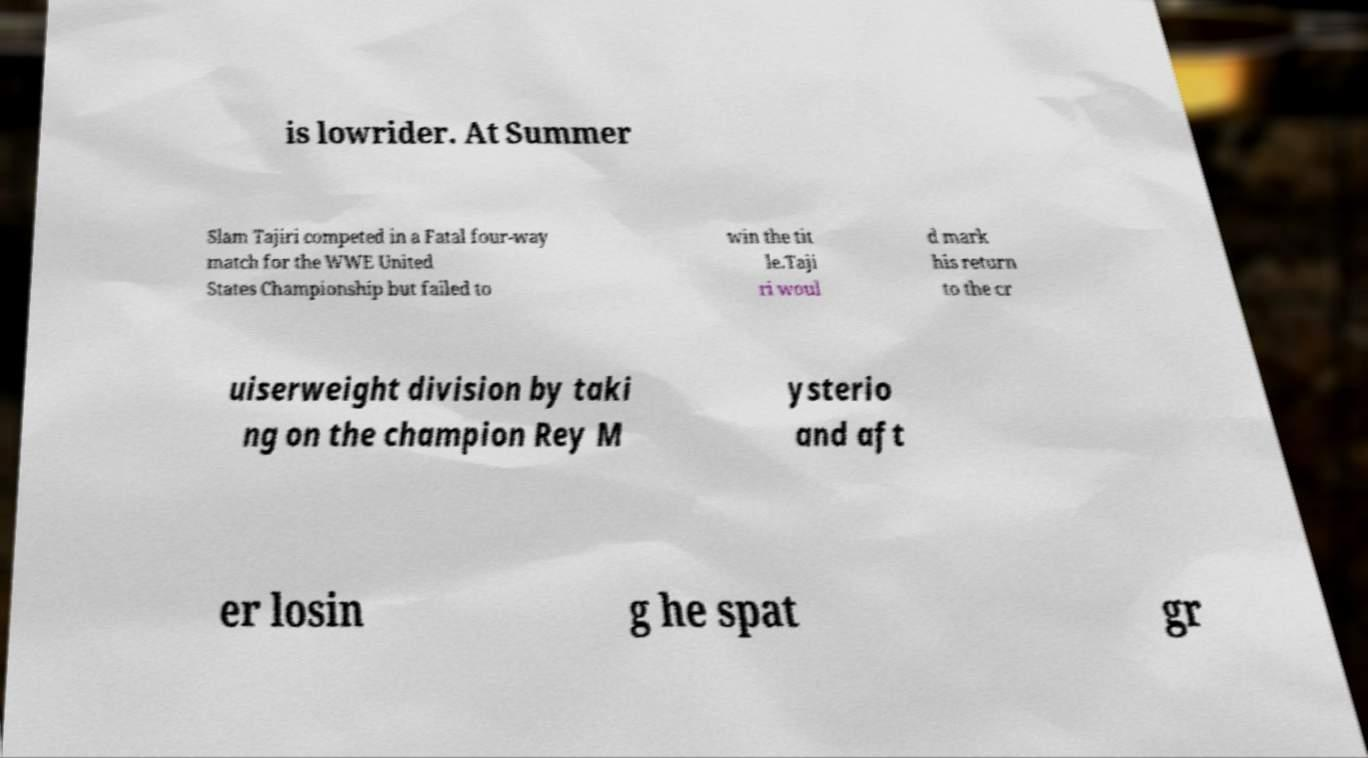Please identify and transcribe the text found in this image. is lowrider. At Summer Slam Tajiri competed in a Fatal four-way match for the WWE United States Championship but failed to win the tit le.Taji ri woul d mark his return to the cr uiserweight division by taki ng on the champion Rey M ysterio and aft er losin g he spat gr 